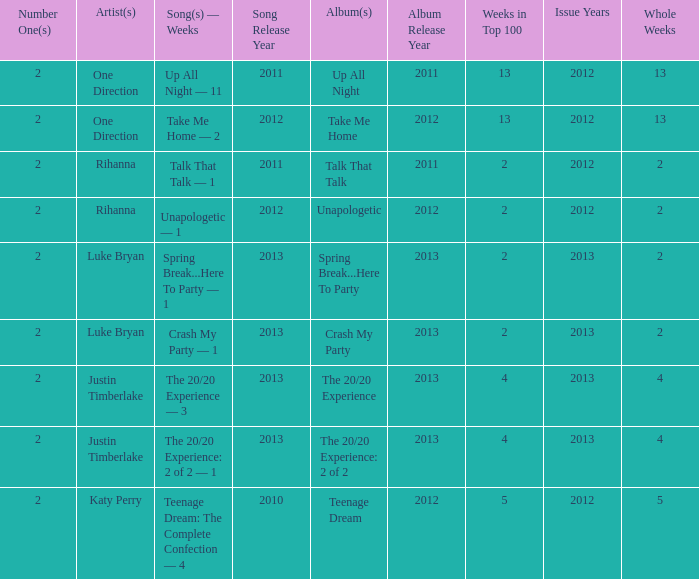What is the title of every song, and how many weeks was each song at #1 for One Direction? Up All Night — 11, Take Me Home — 2. 